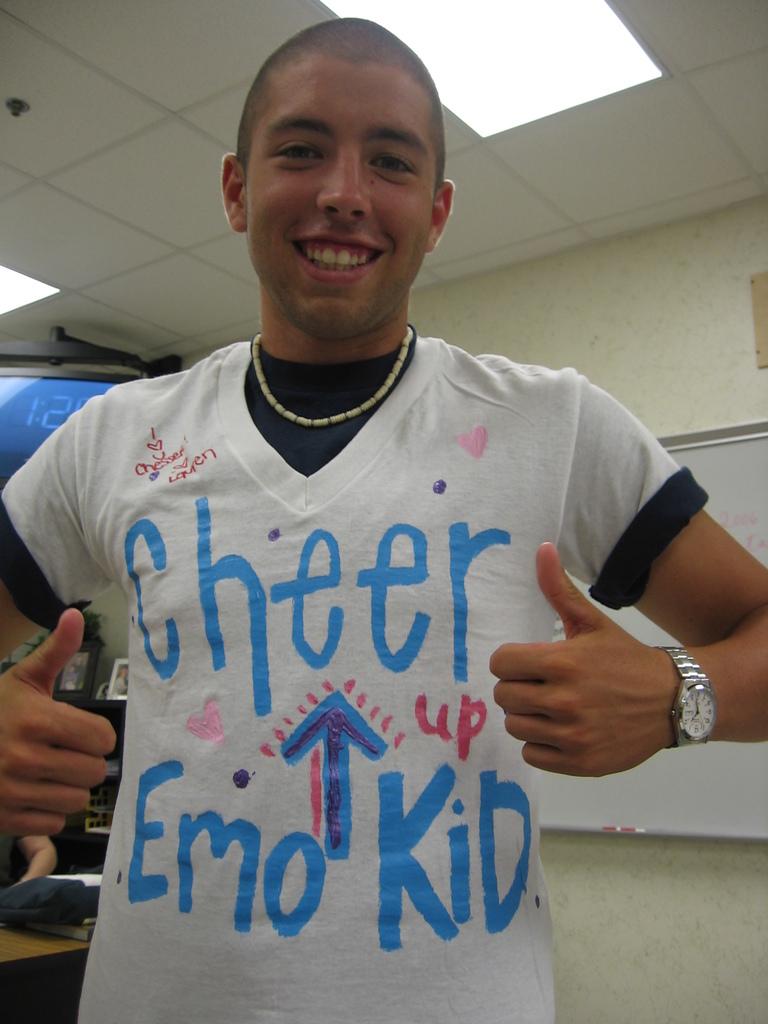Who needs to cheer up?
Keep it short and to the point. Emo kid. 